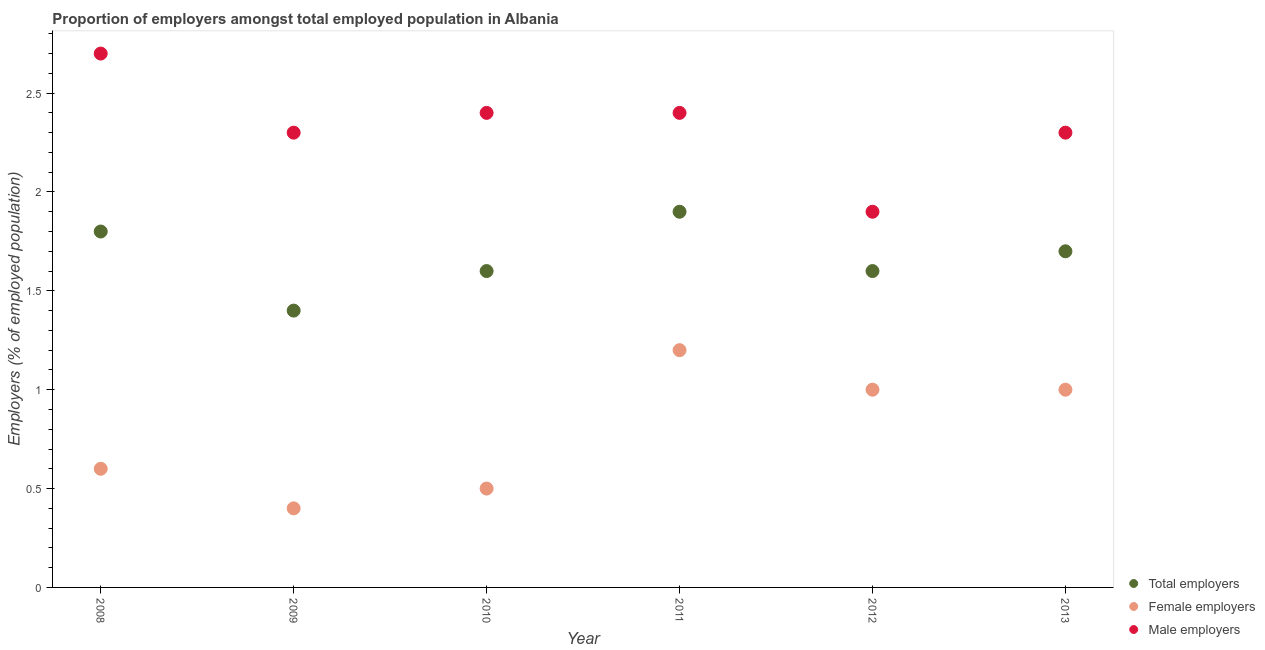How many different coloured dotlines are there?
Your answer should be compact. 3. What is the percentage of female employers in 2011?
Give a very brief answer. 1.2. Across all years, what is the maximum percentage of female employers?
Your answer should be compact. 1.2. Across all years, what is the minimum percentage of male employers?
Your response must be concise. 1.9. In which year was the percentage of male employers minimum?
Ensure brevity in your answer.  2012. What is the total percentage of total employers in the graph?
Make the answer very short. 10. What is the difference between the percentage of female employers in 2009 and that in 2013?
Ensure brevity in your answer.  -0.6. What is the difference between the percentage of male employers in 2012 and the percentage of total employers in 2013?
Ensure brevity in your answer.  0.2. What is the average percentage of female employers per year?
Keep it short and to the point. 0.78. In the year 2009, what is the difference between the percentage of female employers and percentage of male employers?
Give a very brief answer. -1.9. What is the ratio of the percentage of male employers in 2010 to that in 2012?
Make the answer very short. 1.26. Is the difference between the percentage of male employers in 2010 and 2013 greater than the difference between the percentage of female employers in 2010 and 2013?
Make the answer very short. Yes. What is the difference between the highest and the second highest percentage of total employers?
Offer a very short reply. 0.1. What is the difference between the highest and the lowest percentage of male employers?
Make the answer very short. 0.8. Does the percentage of female employers monotonically increase over the years?
Provide a succinct answer. No. Is the percentage of female employers strictly less than the percentage of male employers over the years?
Make the answer very short. Yes. How many years are there in the graph?
Offer a terse response. 6. Are the values on the major ticks of Y-axis written in scientific E-notation?
Offer a terse response. No. Does the graph contain grids?
Your answer should be very brief. No. Where does the legend appear in the graph?
Ensure brevity in your answer.  Bottom right. How are the legend labels stacked?
Make the answer very short. Vertical. What is the title of the graph?
Provide a succinct answer. Proportion of employers amongst total employed population in Albania. Does "Capital account" appear as one of the legend labels in the graph?
Your answer should be very brief. No. What is the label or title of the Y-axis?
Provide a short and direct response. Employers (% of employed population). What is the Employers (% of employed population) of Total employers in 2008?
Provide a short and direct response. 1.8. What is the Employers (% of employed population) in Female employers in 2008?
Provide a succinct answer. 0.6. What is the Employers (% of employed population) of Male employers in 2008?
Offer a terse response. 2.7. What is the Employers (% of employed population) of Total employers in 2009?
Ensure brevity in your answer.  1.4. What is the Employers (% of employed population) in Female employers in 2009?
Ensure brevity in your answer.  0.4. What is the Employers (% of employed population) of Male employers in 2009?
Provide a succinct answer. 2.3. What is the Employers (% of employed population) in Total employers in 2010?
Your response must be concise. 1.6. What is the Employers (% of employed population) of Female employers in 2010?
Your answer should be very brief. 0.5. What is the Employers (% of employed population) in Male employers in 2010?
Provide a succinct answer. 2.4. What is the Employers (% of employed population) in Total employers in 2011?
Give a very brief answer. 1.9. What is the Employers (% of employed population) in Female employers in 2011?
Offer a very short reply. 1.2. What is the Employers (% of employed population) of Male employers in 2011?
Keep it short and to the point. 2.4. What is the Employers (% of employed population) in Total employers in 2012?
Provide a short and direct response. 1.6. What is the Employers (% of employed population) of Female employers in 2012?
Provide a succinct answer. 1. What is the Employers (% of employed population) of Male employers in 2012?
Offer a very short reply. 1.9. What is the Employers (% of employed population) of Total employers in 2013?
Give a very brief answer. 1.7. What is the Employers (% of employed population) of Female employers in 2013?
Offer a terse response. 1. What is the Employers (% of employed population) of Male employers in 2013?
Your response must be concise. 2.3. Across all years, what is the maximum Employers (% of employed population) of Total employers?
Provide a short and direct response. 1.9. Across all years, what is the maximum Employers (% of employed population) of Female employers?
Your answer should be very brief. 1.2. Across all years, what is the maximum Employers (% of employed population) of Male employers?
Your response must be concise. 2.7. Across all years, what is the minimum Employers (% of employed population) in Total employers?
Your answer should be compact. 1.4. Across all years, what is the minimum Employers (% of employed population) of Female employers?
Your answer should be compact. 0.4. Across all years, what is the minimum Employers (% of employed population) of Male employers?
Offer a very short reply. 1.9. What is the total Employers (% of employed population) in Total employers in the graph?
Offer a very short reply. 10. What is the difference between the Employers (% of employed population) of Male employers in 2008 and that in 2009?
Offer a terse response. 0.4. What is the difference between the Employers (% of employed population) in Total employers in 2008 and that in 2010?
Ensure brevity in your answer.  0.2. What is the difference between the Employers (% of employed population) of Female employers in 2008 and that in 2010?
Your answer should be compact. 0.1. What is the difference between the Employers (% of employed population) of Female employers in 2008 and that in 2011?
Keep it short and to the point. -0.6. What is the difference between the Employers (% of employed population) in Total employers in 2008 and that in 2012?
Offer a terse response. 0.2. What is the difference between the Employers (% of employed population) in Female employers in 2008 and that in 2012?
Keep it short and to the point. -0.4. What is the difference between the Employers (% of employed population) of Male employers in 2008 and that in 2012?
Your answer should be compact. 0.8. What is the difference between the Employers (% of employed population) in Male employers in 2008 and that in 2013?
Offer a terse response. 0.4. What is the difference between the Employers (% of employed population) in Total employers in 2009 and that in 2010?
Offer a very short reply. -0.2. What is the difference between the Employers (% of employed population) in Female employers in 2009 and that in 2010?
Your answer should be compact. -0.1. What is the difference between the Employers (% of employed population) in Female employers in 2009 and that in 2011?
Keep it short and to the point. -0.8. What is the difference between the Employers (% of employed population) in Total employers in 2009 and that in 2012?
Offer a very short reply. -0.2. What is the difference between the Employers (% of employed population) of Female employers in 2009 and that in 2012?
Ensure brevity in your answer.  -0.6. What is the difference between the Employers (% of employed population) in Female employers in 2009 and that in 2013?
Ensure brevity in your answer.  -0.6. What is the difference between the Employers (% of employed population) in Total employers in 2010 and that in 2011?
Your response must be concise. -0.3. What is the difference between the Employers (% of employed population) in Female employers in 2010 and that in 2011?
Offer a very short reply. -0.7. What is the difference between the Employers (% of employed population) in Total employers in 2010 and that in 2012?
Provide a succinct answer. 0. What is the difference between the Employers (% of employed population) of Female employers in 2010 and that in 2012?
Your response must be concise. -0.5. What is the difference between the Employers (% of employed population) of Total employers in 2010 and that in 2013?
Your answer should be compact. -0.1. What is the difference between the Employers (% of employed population) of Male employers in 2011 and that in 2012?
Give a very brief answer. 0.5. What is the difference between the Employers (% of employed population) of Total employers in 2011 and that in 2013?
Offer a terse response. 0.2. What is the difference between the Employers (% of employed population) of Female employers in 2011 and that in 2013?
Provide a short and direct response. 0.2. What is the difference between the Employers (% of employed population) in Total employers in 2012 and that in 2013?
Your answer should be very brief. -0.1. What is the difference between the Employers (% of employed population) in Female employers in 2012 and that in 2013?
Give a very brief answer. 0. What is the difference between the Employers (% of employed population) in Male employers in 2012 and that in 2013?
Keep it short and to the point. -0.4. What is the difference between the Employers (% of employed population) of Total employers in 2008 and the Employers (% of employed population) of Female employers in 2009?
Ensure brevity in your answer.  1.4. What is the difference between the Employers (% of employed population) in Total employers in 2008 and the Employers (% of employed population) in Female employers in 2010?
Keep it short and to the point. 1.3. What is the difference between the Employers (% of employed population) in Total employers in 2008 and the Employers (% of employed population) in Male employers in 2010?
Keep it short and to the point. -0.6. What is the difference between the Employers (% of employed population) of Total employers in 2008 and the Employers (% of employed population) of Female employers in 2011?
Your answer should be compact. 0.6. What is the difference between the Employers (% of employed population) of Total employers in 2008 and the Employers (% of employed population) of Male employers in 2011?
Provide a succinct answer. -0.6. What is the difference between the Employers (% of employed population) in Female employers in 2008 and the Employers (% of employed population) in Male employers in 2011?
Your answer should be very brief. -1.8. What is the difference between the Employers (% of employed population) in Female employers in 2008 and the Employers (% of employed population) in Male employers in 2012?
Make the answer very short. -1.3. What is the difference between the Employers (% of employed population) of Total employers in 2008 and the Employers (% of employed population) of Male employers in 2013?
Offer a very short reply. -0.5. What is the difference between the Employers (% of employed population) in Total employers in 2009 and the Employers (% of employed population) in Male employers in 2010?
Provide a short and direct response. -1. What is the difference between the Employers (% of employed population) in Female employers in 2009 and the Employers (% of employed population) in Male employers in 2010?
Provide a short and direct response. -2. What is the difference between the Employers (% of employed population) of Total employers in 2009 and the Employers (% of employed population) of Male employers in 2011?
Your answer should be compact. -1. What is the difference between the Employers (% of employed population) in Total employers in 2009 and the Employers (% of employed population) in Female employers in 2012?
Offer a terse response. 0.4. What is the difference between the Employers (% of employed population) of Total employers in 2009 and the Employers (% of employed population) of Male employers in 2012?
Your answer should be very brief. -0.5. What is the difference between the Employers (% of employed population) in Female employers in 2009 and the Employers (% of employed population) in Male employers in 2013?
Offer a very short reply. -1.9. What is the difference between the Employers (% of employed population) of Total employers in 2010 and the Employers (% of employed population) of Female employers in 2011?
Ensure brevity in your answer.  0.4. What is the difference between the Employers (% of employed population) of Female employers in 2010 and the Employers (% of employed population) of Male employers in 2011?
Give a very brief answer. -1.9. What is the difference between the Employers (% of employed population) in Total employers in 2010 and the Employers (% of employed population) in Female employers in 2012?
Provide a short and direct response. 0.6. What is the difference between the Employers (% of employed population) in Total employers in 2010 and the Employers (% of employed population) in Female employers in 2013?
Your answer should be very brief. 0.6. What is the difference between the Employers (% of employed population) in Total employers in 2010 and the Employers (% of employed population) in Male employers in 2013?
Your answer should be very brief. -0.7. What is the difference between the Employers (% of employed population) of Total employers in 2011 and the Employers (% of employed population) of Female employers in 2013?
Give a very brief answer. 0.9. What is the difference between the Employers (% of employed population) in Total employers in 2011 and the Employers (% of employed population) in Male employers in 2013?
Offer a terse response. -0.4. What is the difference between the Employers (% of employed population) of Female employers in 2011 and the Employers (% of employed population) of Male employers in 2013?
Make the answer very short. -1.1. What is the difference between the Employers (% of employed population) of Total employers in 2012 and the Employers (% of employed population) of Female employers in 2013?
Your response must be concise. 0.6. What is the difference between the Employers (% of employed population) of Female employers in 2012 and the Employers (% of employed population) of Male employers in 2013?
Offer a terse response. -1.3. What is the average Employers (% of employed population) of Total employers per year?
Offer a terse response. 1.67. What is the average Employers (% of employed population) in Female employers per year?
Provide a succinct answer. 0.78. What is the average Employers (% of employed population) in Male employers per year?
Provide a succinct answer. 2.33. In the year 2008, what is the difference between the Employers (% of employed population) of Total employers and Employers (% of employed population) of Female employers?
Your response must be concise. 1.2. In the year 2008, what is the difference between the Employers (% of employed population) in Female employers and Employers (% of employed population) in Male employers?
Your response must be concise. -2.1. In the year 2009, what is the difference between the Employers (% of employed population) in Total employers and Employers (% of employed population) in Female employers?
Make the answer very short. 1. In the year 2009, what is the difference between the Employers (% of employed population) of Total employers and Employers (% of employed population) of Male employers?
Provide a succinct answer. -0.9. In the year 2010, what is the difference between the Employers (% of employed population) in Total employers and Employers (% of employed population) in Female employers?
Provide a short and direct response. 1.1. In the year 2010, what is the difference between the Employers (% of employed population) in Total employers and Employers (% of employed population) in Male employers?
Ensure brevity in your answer.  -0.8. In the year 2010, what is the difference between the Employers (% of employed population) in Female employers and Employers (% of employed population) in Male employers?
Provide a succinct answer. -1.9. In the year 2011, what is the difference between the Employers (% of employed population) of Female employers and Employers (% of employed population) of Male employers?
Offer a terse response. -1.2. In the year 2012, what is the difference between the Employers (% of employed population) in Total employers and Employers (% of employed population) in Male employers?
Give a very brief answer. -0.3. In the year 2013, what is the difference between the Employers (% of employed population) in Total employers and Employers (% of employed population) in Female employers?
Offer a very short reply. 0.7. In the year 2013, what is the difference between the Employers (% of employed population) in Total employers and Employers (% of employed population) in Male employers?
Provide a short and direct response. -0.6. In the year 2013, what is the difference between the Employers (% of employed population) of Female employers and Employers (% of employed population) of Male employers?
Provide a short and direct response. -1.3. What is the ratio of the Employers (% of employed population) in Male employers in 2008 to that in 2009?
Provide a succinct answer. 1.17. What is the ratio of the Employers (% of employed population) in Total employers in 2008 to that in 2010?
Ensure brevity in your answer.  1.12. What is the ratio of the Employers (% of employed population) in Female employers in 2008 to that in 2010?
Your answer should be very brief. 1.2. What is the ratio of the Employers (% of employed population) in Male employers in 2008 to that in 2010?
Your answer should be very brief. 1.12. What is the ratio of the Employers (% of employed population) of Total employers in 2008 to that in 2011?
Offer a terse response. 0.95. What is the ratio of the Employers (% of employed population) in Total employers in 2008 to that in 2012?
Offer a very short reply. 1.12. What is the ratio of the Employers (% of employed population) of Male employers in 2008 to that in 2012?
Offer a terse response. 1.42. What is the ratio of the Employers (% of employed population) of Total employers in 2008 to that in 2013?
Provide a succinct answer. 1.06. What is the ratio of the Employers (% of employed population) of Male employers in 2008 to that in 2013?
Provide a short and direct response. 1.17. What is the ratio of the Employers (% of employed population) in Total employers in 2009 to that in 2010?
Make the answer very short. 0.88. What is the ratio of the Employers (% of employed population) in Male employers in 2009 to that in 2010?
Give a very brief answer. 0.96. What is the ratio of the Employers (% of employed population) of Total employers in 2009 to that in 2011?
Keep it short and to the point. 0.74. What is the ratio of the Employers (% of employed population) of Female employers in 2009 to that in 2011?
Your response must be concise. 0.33. What is the ratio of the Employers (% of employed population) in Female employers in 2009 to that in 2012?
Offer a terse response. 0.4. What is the ratio of the Employers (% of employed population) in Male employers in 2009 to that in 2012?
Offer a terse response. 1.21. What is the ratio of the Employers (% of employed population) in Total employers in 2009 to that in 2013?
Offer a very short reply. 0.82. What is the ratio of the Employers (% of employed population) of Total employers in 2010 to that in 2011?
Your response must be concise. 0.84. What is the ratio of the Employers (% of employed population) in Female employers in 2010 to that in 2011?
Your answer should be very brief. 0.42. What is the ratio of the Employers (% of employed population) of Male employers in 2010 to that in 2011?
Provide a short and direct response. 1. What is the ratio of the Employers (% of employed population) in Total employers in 2010 to that in 2012?
Offer a very short reply. 1. What is the ratio of the Employers (% of employed population) in Male employers in 2010 to that in 2012?
Give a very brief answer. 1.26. What is the ratio of the Employers (% of employed population) of Female employers in 2010 to that in 2013?
Give a very brief answer. 0.5. What is the ratio of the Employers (% of employed population) of Male employers in 2010 to that in 2013?
Provide a short and direct response. 1.04. What is the ratio of the Employers (% of employed population) of Total employers in 2011 to that in 2012?
Keep it short and to the point. 1.19. What is the ratio of the Employers (% of employed population) in Male employers in 2011 to that in 2012?
Your response must be concise. 1.26. What is the ratio of the Employers (% of employed population) in Total employers in 2011 to that in 2013?
Offer a very short reply. 1.12. What is the ratio of the Employers (% of employed population) of Male employers in 2011 to that in 2013?
Make the answer very short. 1.04. What is the ratio of the Employers (% of employed population) of Female employers in 2012 to that in 2013?
Make the answer very short. 1. What is the ratio of the Employers (% of employed population) in Male employers in 2012 to that in 2013?
Your answer should be very brief. 0.83. What is the difference between the highest and the second highest Employers (% of employed population) in Total employers?
Ensure brevity in your answer.  0.1. What is the difference between the highest and the second highest Employers (% of employed population) of Female employers?
Your answer should be compact. 0.2. What is the difference between the highest and the lowest Employers (% of employed population) in Total employers?
Offer a very short reply. 0.5. What is the difference between the highest and the lowest Employers (% of employed population) in Male employers?
Your answer should be compact. 0.8. 